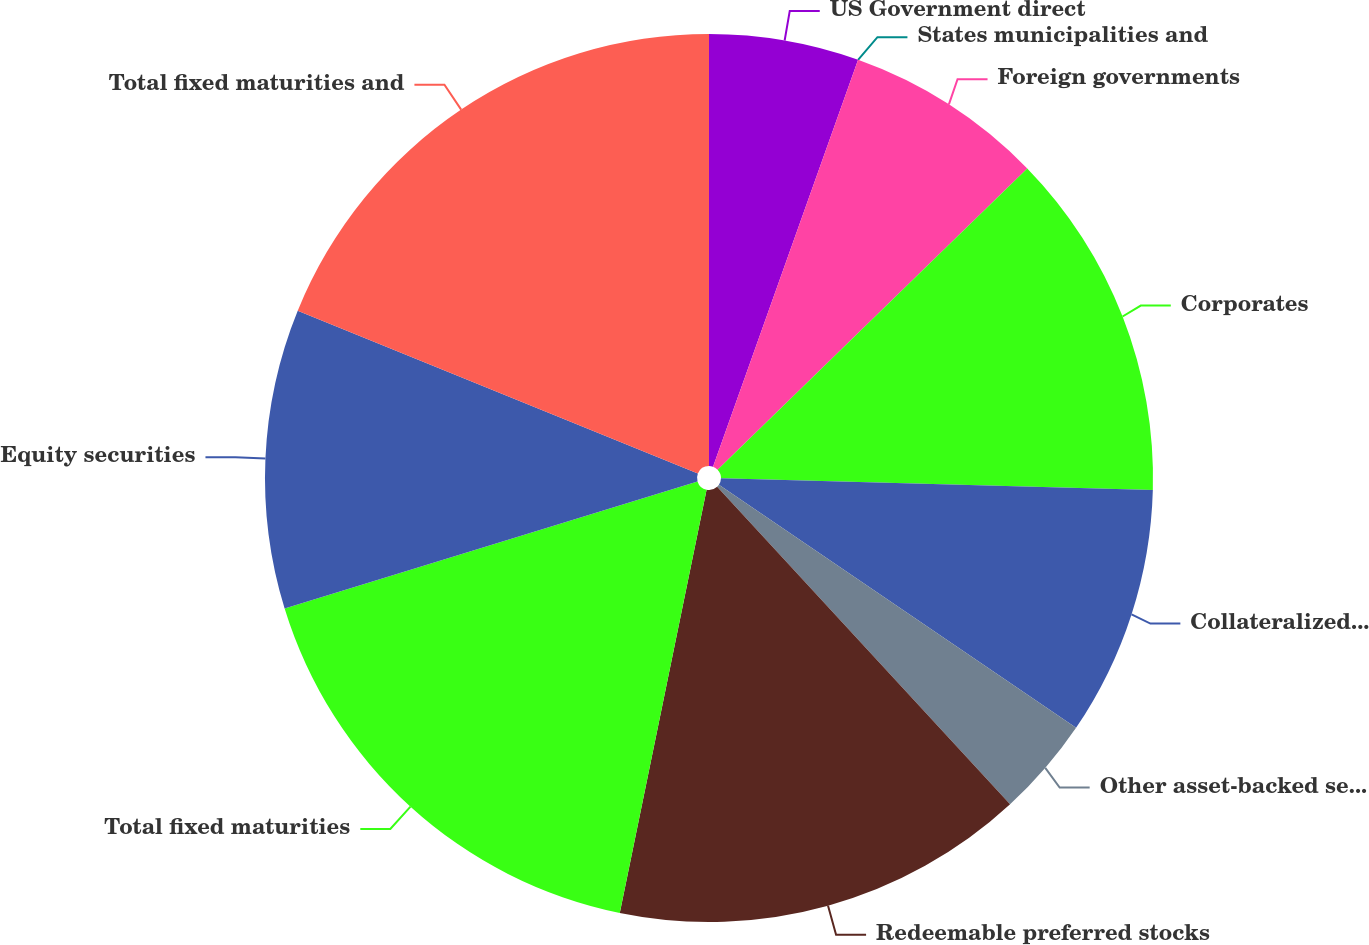<chart> <loc_0><loc_0><loc_500><loc_500><pie_chart><fcel>US Government direct<fcel>States municipalities and<fcel>Foreign governments<fcel>Corporates<fcel>Collateralized debt<fcel>Other asset-backed securities<fcel>Redeemable preferred stocks<fcel>Total fixed maturities<fcel>Equity securities<fcel>Total fixed maturities and<nl><fcel>5.45%<fcel>0.0%<fcel>7.27%<fcel>12.71%<fcel>9.08%<fcel>3.63%<fcel>15.08%<fcel>17.03%<fcel>10.9%<fcel>18.85%<nl></chart> 